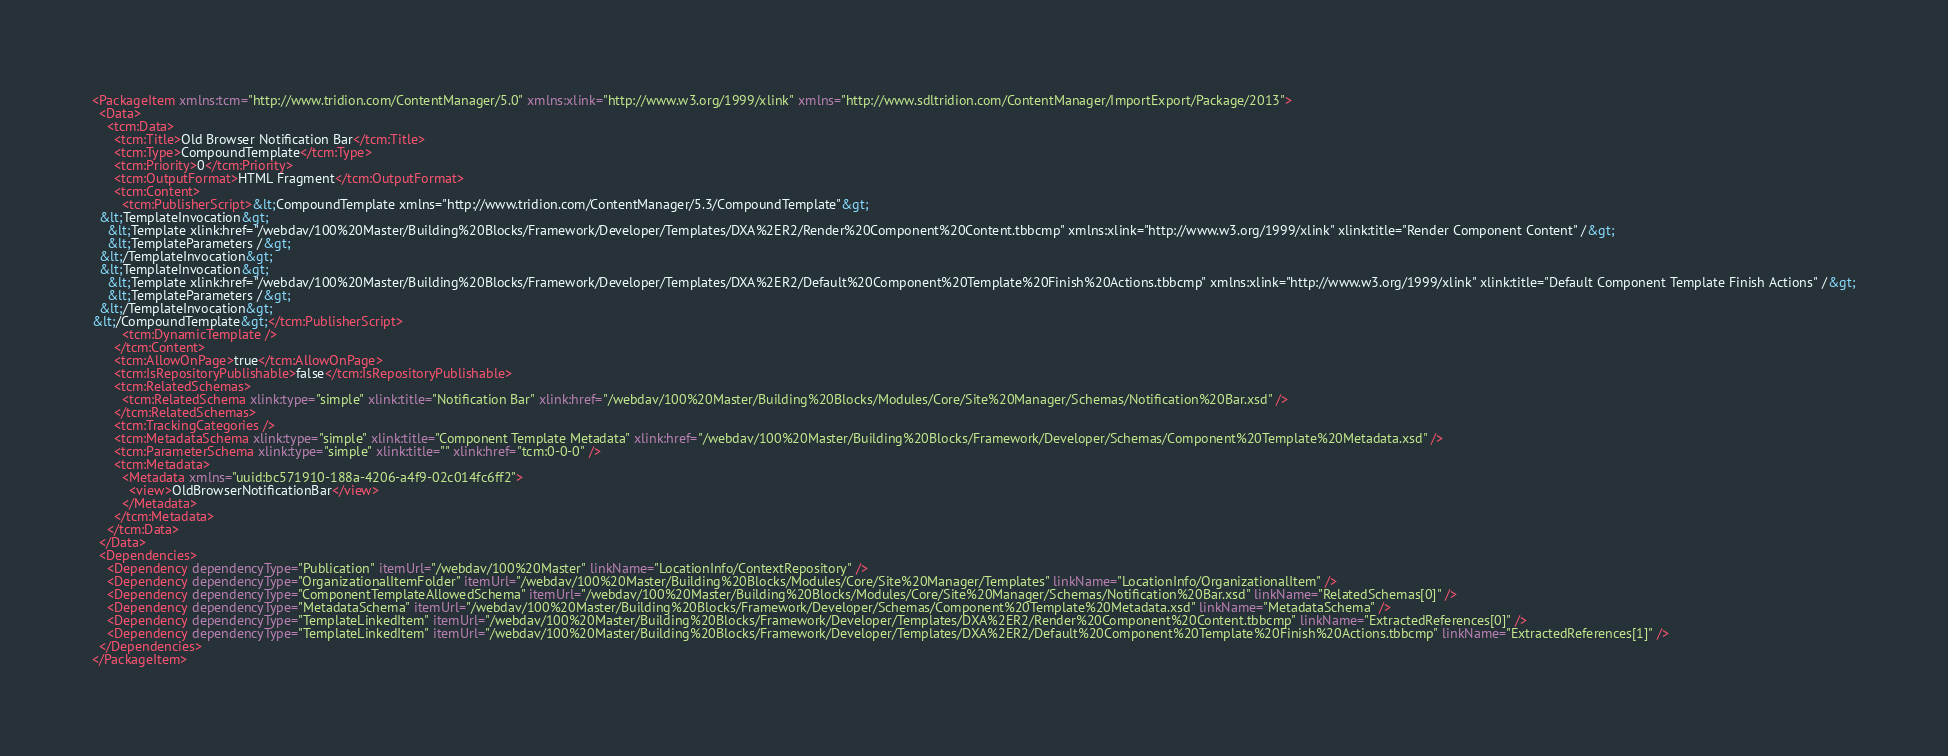<code> <loc_0><loc_0><loc_500><loc_500><_XML_><PackageItem xmlns:tcm="http://www.tridion.com/ContentManager/5.0" xmlns:xlink="http://www.w3.org/1999/xlink" xmlns="http://www.sdltridion.com/ContentManager/ImportExport/Package/2013">
  <Data>
    <tcm:Data>
      <tcm:Title>Old Browser Notification Bar</tcm:Title>
      <tcm:Type>CompoundTemplate</tcm:Type>
      <tcm:Priority>0</tcm:Priority>
      <tcm:OutputFormat>HTML Fragment</tcm:OutputFormat>
      <tcm:Content>
        <tcm:PublisherScript>&lt;CompoundTemplate xmlns="http://www.tridion.com/ContentManager/5.3/CompoundTemplate"&gt;
  &lt;TemplateInvocation&gt;
    &lt;Template xlink:href="/webdav/100%20Master/Building%20Blocks/Framework/Developer/Templates/DXA%2ER2/Render%20Component%20Content.tbbcmp" xmlns:xlink="http://www.w3.org/1999/xlink" xlink:title="Render Component Content" /&gt;
    &lt;TemplateParameters /&gt;
  &lt;/TemplateInvocation&gt;
  &lt;TemplateInvocation&gt;
    &lt;Template xlink:href="/webdav/100%20Master/Building%20Blocks/Framework/Developer/Templates/DXA%2ER2/Default%20Component%20Template%20Finish%20Actions.tbbcmp" xmlns:xlink="http://www.w3.org/1999/xlink" xlink:title="Default Component Template Finish Actions" /&gt;
    &lt;TemplateParameters /&gt;
  &lt;/TemplateInvocation&gt;
&lt;/CompoundTemplate&gt;</tcm:PublisherScript>
        <tcm:DynamicTemplate />
      </tcm:Content>
      <tcm:AllowOnPage>true</tcm:AllowOnPage>
      <tcm:IsRepositoryPublishable>false</tcm:IsRepositoryPublishable>
      <tcm:RelatedSchemas>
        <tcm:RelatedSchema xlink:type="simple" xlink:title="Notification Bar" xlink:href="/webdav/100%20Master/Building%20Blocks/Modules/Core/Site%20Manager/Schemas/Notification%20Bar.xsd" />
      </tcm:RelatedSchemas>
      <tcm:TrackingCategories />
      <tcm:MetadataSchema xlink:type="simple" xlink:title="Component Template Metadata" xlink:href="/webdav/100%20Master/Building%20Blocks/Framework/Developer/Schemas/Component%20Template%20Metadata.xsd" />
      <tcm:ParameterSchema xlink:type="simple" xlink:title="" xlink:href="tcm:0-0-0" />
      <tcm:Metadata>
        <Metadata xmlns="uuid:bc571910-188a-4206-a4f9-02c014fc6ff2">
          <view>OldBrowserNotificationBar</view>
        </Metadata>
      </tcm:Metadata>
    </tcm:Data>
  </Data>
  <Dependencies>
    <Dependency dependencyType="Publication" itemUrl="/webdav/100%20Master" linkName="LocationInfo/ContextRepository" />
    <Dependency dependencyType="OrganizationalItemFolder" itemUrl="/webdav/100%20Master/Building%20Blocks/Modules/Core/Site%20Manager/Templates" linkName="LocationInfo/OrganizationalItem" />
    <Dependency dependencyType="ComponentTemplateAllowedSchema" itemUrl="/webdav/100%20Master/Building%20Blocks/Modules/Core/Site%20Manager/Schemas/Notification%20Bar.xsd" linkName="RelatedSchemas[0]" />
    <Dependency dependencyType="MetadataSchema" itemUrl="/webdav/100%20Master/Building%20Blocks/Framework/Developer/Schemas/Component%20Template%20Metadata.xsd" linkName="MetadataSchema" />
    <Dependency dependencyType="TemplateLinkedItem" itemUrl="/webdav/100%20Master/Building%20Blocks/Framework/Developer/Templates/DXA%2ER2/Render%20Component%20Content.tbbcmp" linkName="ExtractedReferences[0]" />
    <Dependency dependencyType="TemplateLinkedItem" itemUrl="/webdav/100%20Master/Building%20Blocks/Framework/Developer/Templates/DXA%2ER2/Default%20Component%20Template%20Finish%20Actions.tbbcmp" linkName="ExtractedReferences[1]" />
  </Dependencies>
</PackageItem></code> 